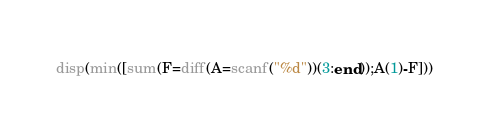<code> <loc_0><loc_0><loc_500><loc_500><_Octave_>disp(min([sum(F=diff(A=scanf("%d"))(3:end));A(1)-F]))</code> 